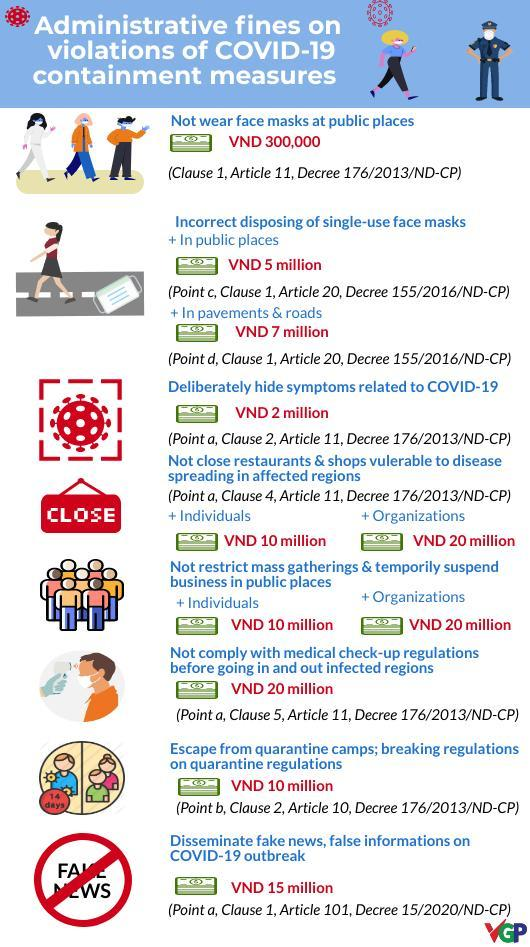How many corona virus icons are shown?
Answer the question with a short phrase. 5 How many currency icons are shown? 11 What is the fine for incorrect disposing of single use face masks in public places and in pavements & roads? VND 12 million 